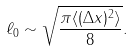<formula> <loc_0><loc_0><loc_500><loc_500>\ell _ { 0 } \sim \sqrt { \frac { \pi \langle ( \Delta x ) ^ { 2 } \rangle } { 8 } } .</formula> 